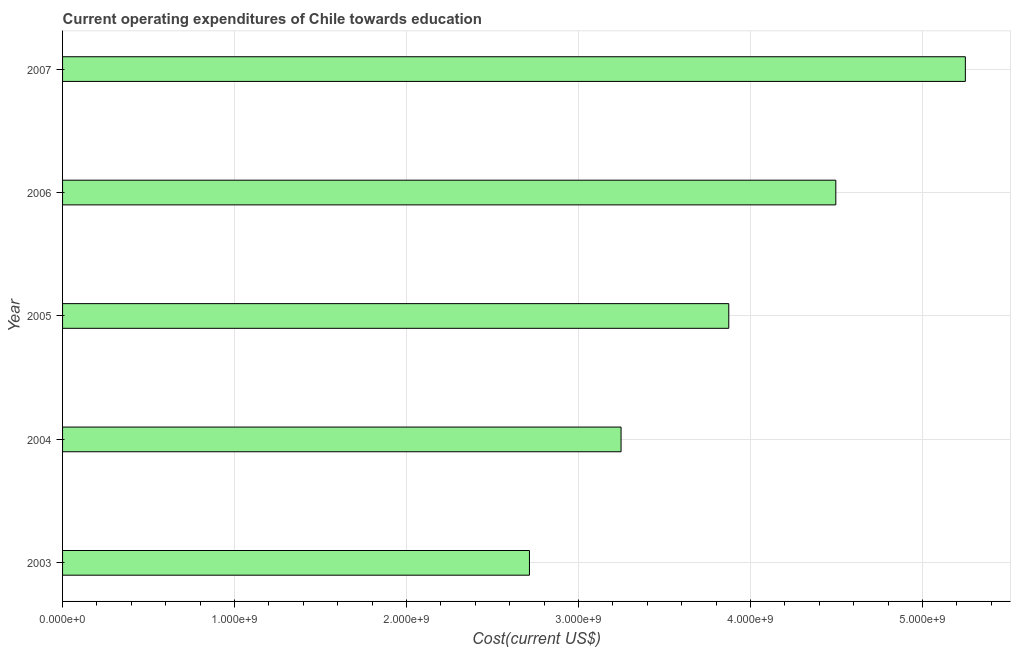What is the title of the graph?
Provide a short and direct response. Current operating expenditures of Chile towards education. What is the label or title of the X-axis?
Your answer should be very brief. Cost(current US$). What is the education expenditure in 2006?
Your answer should be very brief. 4.50e+09. Across all years, what is the maximum education expenditure?
Give a very brief answer. 5.25e+09. Across all years, what is the minimum education expenditure?
Ensure brevity in your answer.  2.72e+09. In which year was the education expenditure maximum?
Your answer should be very brief. 2007. What is the sum of the education expenditure?
Offer a terse response. 1.96e+1. What is the difference between the education expenditure in 2003 and 2006?
Ensure brevity in your answer.  -1.78e+09. What is the average education expenditure per year?
Your answer should be very brief. 3.92e+09. What is the median education expenditure?
Keep it short and to the point. 3.87e+09. In how many years, is the education expenditure greater than 5200000000 US$?
Make the answer very short. 1. Do a majority of the years between 2003 and 2006 (inclusive) have education expenditure greater than 3600000000 US$?
Your answer should be very brief. No. What is the ratio of the education expenditure in 2003 to that in 2005?
Provide a short and direct response. 0.7. Is the education expenditure in 2003 less than that in 2005?
Make the answer very short. Yes. Is the difference between the education expenditure in 2003 and 2005 greater than the difference between any two years?
Offer a terse response. No. What is the difference between the highest and the second highest education expenditure?
Your answer should be very brief. 7.53e+08. What is the difference between the highest and the lowest education expenditure?
Your response must be concise. 2.53e+09. How many bars are there?
Give a very brief answer. 5. Are all the bars in the graph horizontal?
Your answer should be very brief. Yes. What is the difference between two consecutive major ticks on the X-axis?
Make the answer very short. 1.00e+09. What is the Cost(current US$) in 2003?
Your answer should be compact. 2.72e+09. What is the Cost(current US$) in 2004?
Your answer should be very brief. 3.25e+09. What is the Cost(current US$) in 2005?
Make the answer very short. 3.87e+09. What is the Cost(current US$) of 2006?
Ensure brevity in your answer.  4.50e+09. What is the Cost(current US$) of 2007?
Provide a short and direct response. 5.25e+09. What is the difference between the Cost(current US$) in 2003 and 2004?
Ensure brevity in your answer.  -5.33e+08. What is the difference between the Cost(current US$) in 2003 and 2005?
Keep it short and to the point. -1.16e+09. What is the difference between the Cost(current US$) in 2003 and 2006?
Your answer should be compact. -1.78e+09. What is the difference between the Cost(current US$) in 2003 and 2007?
Your response must be concise. -2.53e+09. What is the difference between the Cost(current US$) in 2004 and 2005?
Your response must be concise. -6.26e+08. What is the difference between the Cost(current US$) in 2004 and 2006?
Give a very brief answer. -1.25e+09. What is the difference between the Cost(current US$) in 2004 and 2007?
Keep it short and to the point. -2.00e+09. What is the difference between the Cost(current US$) in 2005 and 2006?
Your response must be concise. -6.22e+08. What is the difference between the Cost(current US$) in 2005 and 2007?
Your answer should be very brief. -1.38e+09. What is the difference between the Cost(current US$) in 2006 and 2007?
Offer a very short reply. -7.53e+08. What is the ratio of the Cost(current US$) in 2003 to that in 2004?
Offer a very short reply. 0.84. What is the ratio of the Cost(current US$) in 2003 to that in 2005?
Give a very brief answer. 0.7. What is the ratio of the Cost(current US$) in 2003 to that in 2006?
Provide a succinct answer. 0.6. What is the ratio of the Cost(current US$) in 2003 to that in 2007?
Provide a short and direct response. 0.52. What is the ratio of the Cost(current US$) in 2004 to that in 2005?
Provide a short and direct response. 0.84. What is the ratio of the Cost(current US$) in 2004 to that in 2006?
Your answer should be very brief. 0.72. What is the ratio of the Cost(current US$) in 2004 to that in 2007?
Provide a succinct answer. 0.62. What is the ratio of the Cost(current US$) in 2005 to that in 2006?
Offer a terse response. 0.86. What is the ratio of the Cost(current US$) in 2005 to that in 2007?
Ensure brevity in your answer.  0.74. What is the ratio of the Cost(current US$) in 2006 to that in 2007?
Your answer should be compact. 0.86. 